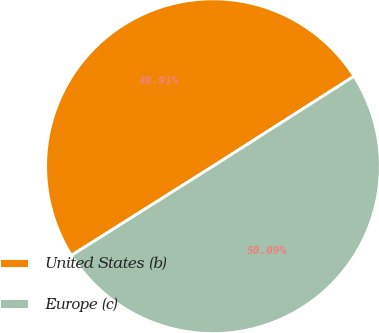Convert chart. <chart><loc_0><loc_0><loc_500><loc_500><pie_chart><fcel>United States (b)<fcel>Europe (c)<nl><fcel>49.91%<fcel>50.09%<nl></chart> 